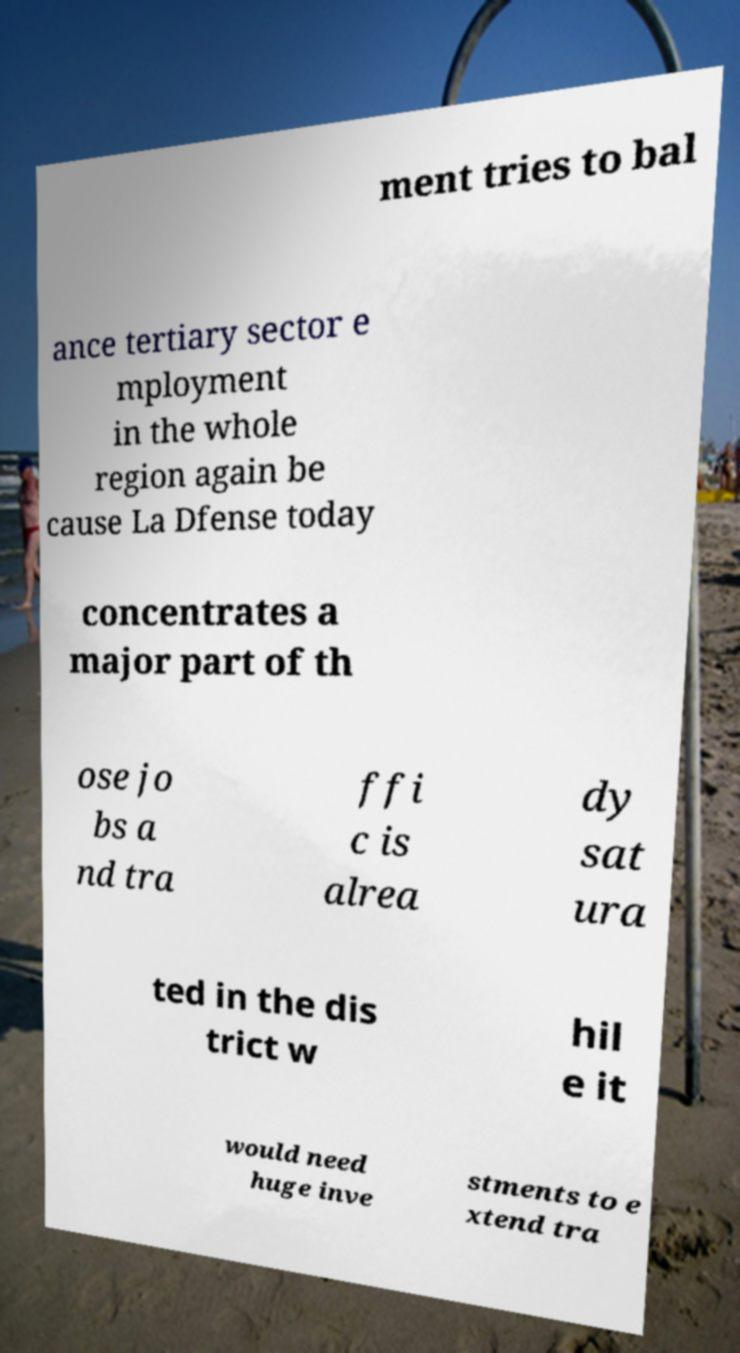Please read and relay the text visible in this image. What does it say? ment tries to bal ance tertiary sector e mployment in the whole region again be cause La Dfense today concentrates a major part of th ose jo bs a nd tra ffi c is alrea dy sat ura ted in the dis trict w hil e it would need huge inve stments to e xtend tra 